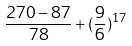Convert formula to latex. <formula><loc_0><loc_0><loc_500><loc_500>\frac { 2 7 0 - 8 7 } { 7 8 } + ( \frac { 9 } { 6 } ) ^ { 1 7 }</formula> 